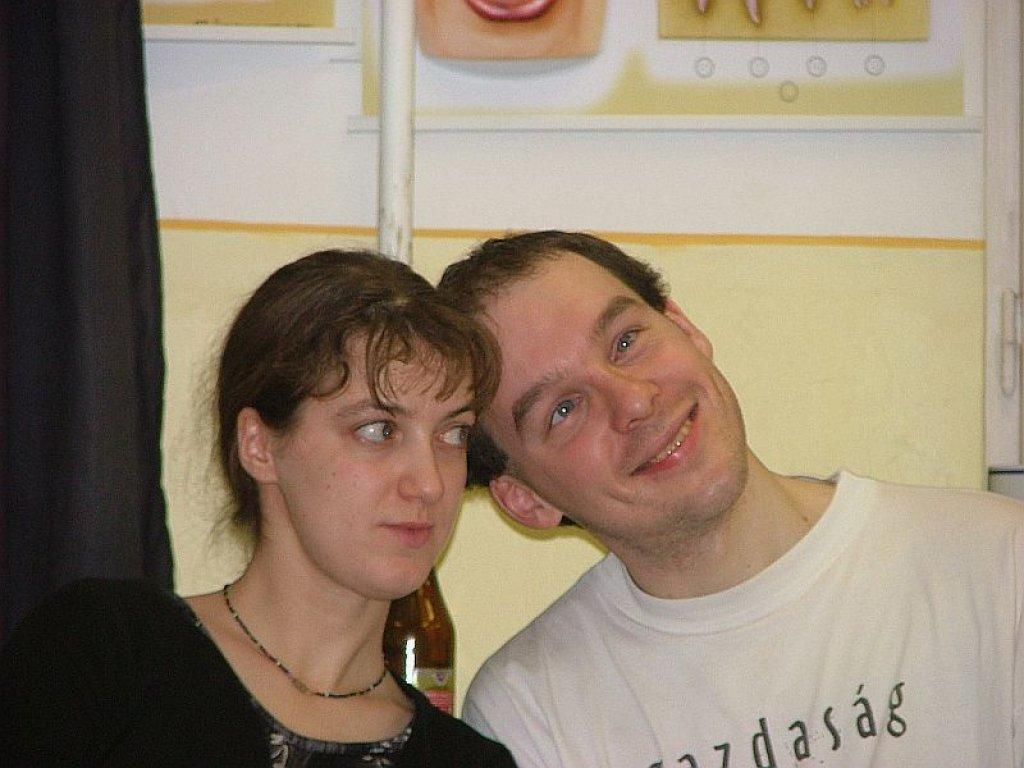In one or two sentences, can you explain what this image depicts? In this image, we can see persons in front of the wall. There is a pole at the top of the image. There is a curtain on the left side of the image. 